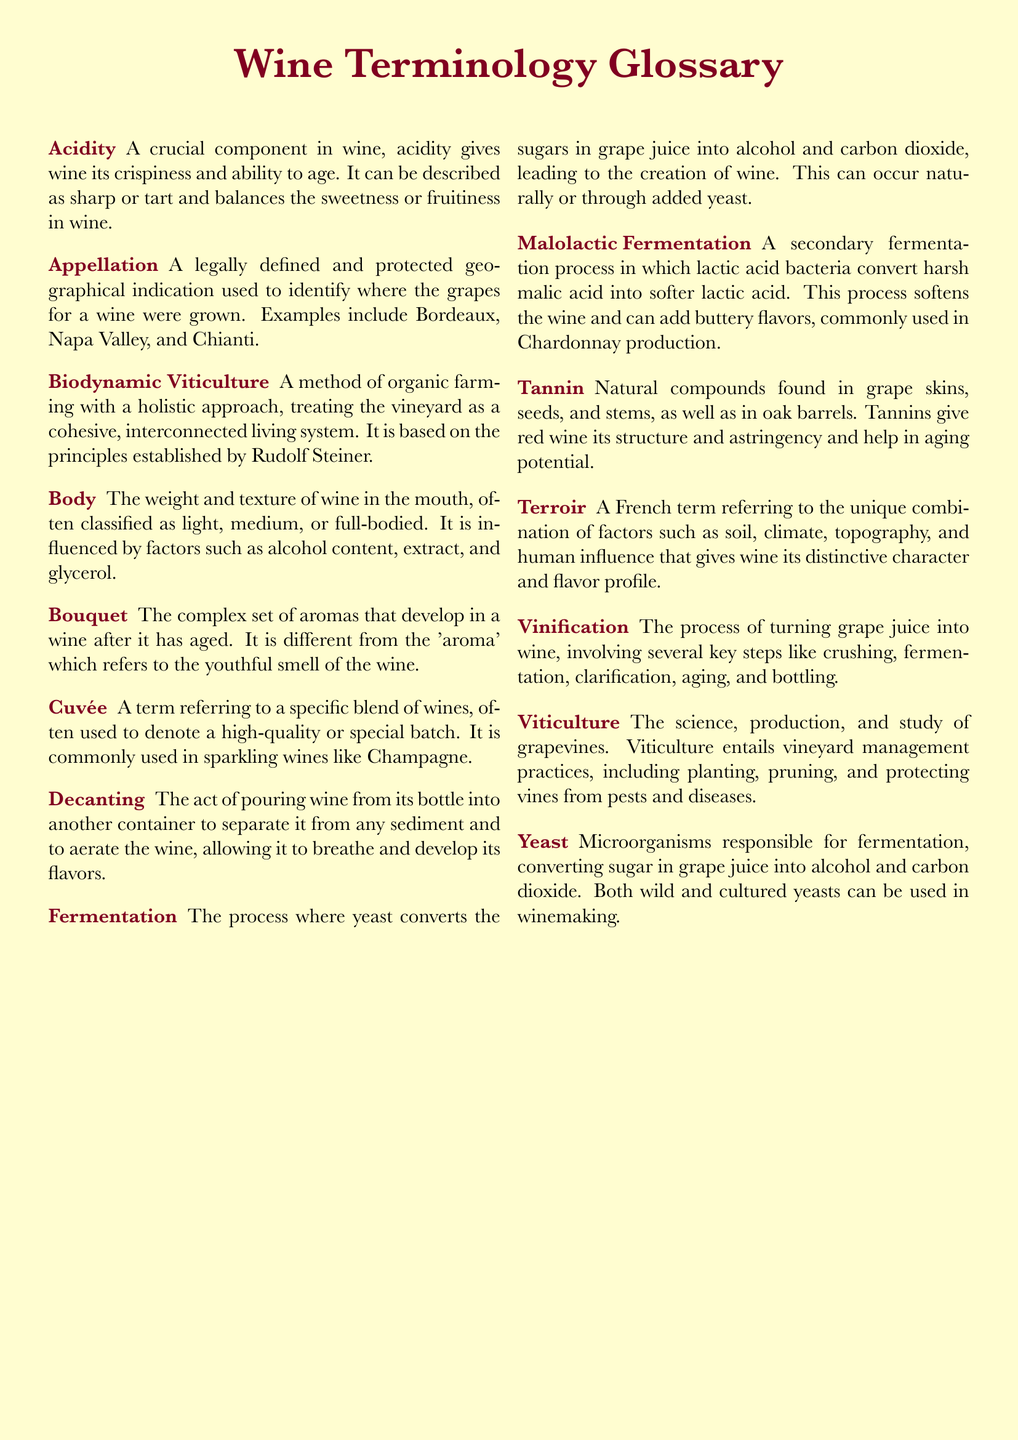What is a legally defined geographical indication used to identify where the grapes for a wine were grown? The term that refers to this is found in the definition of Appellation.
Answer: Appellation What are the two types of fermentation processes mentioned in the document? The two types are detailed in the definitions of Fermentation and Malolactic Fermentation.
Answer: Fermentation and Malolactic Fermentation What weight classification is used to describe the body of wine? The document states that body is classified as light, medium, or full-bodied.
Answer: Light, medium, or full-bodied What process separates wine from sediment and allows it to breathe? This process is described in the definition of Decanting.
Answer: Decanting What are the microorganisms responsible for fermentation in winemaking? The relevant micro-organisms are mentioned in the definition of Yeast.
Answer: Yeast How does acidity contribute to wine quality? Acidity gives wine its crispiness and ability to age, as described in its definition.
Answer: Crispiness and ability to age What influence does terroir have on wine? Terroir contributes to the distinctive character and flavor profile of wine as defined in its entry.
Answer: Distinctive character and flavor profile What is the holistic approach to vineyard management mentioned in the glossary? This approach is defined under Biodynamic Viticulture.
Answer: Biodynamic Viticulture 